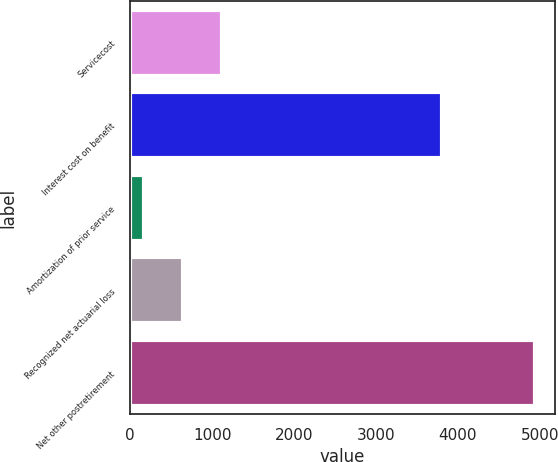<chart> <loc_0><loc_0><loc_500><loc_500><bar_chart><fcel>Servicecost<fcel>Interest cost on benefit<fcel>Amortization of prior service<fcel>Recognized net actuarial loss<fcel>Net other postretirement<nl><fcel>1123.2<fcel>3811<fcel>170<fcel>646.6<fcel>4936<nl></chart> 